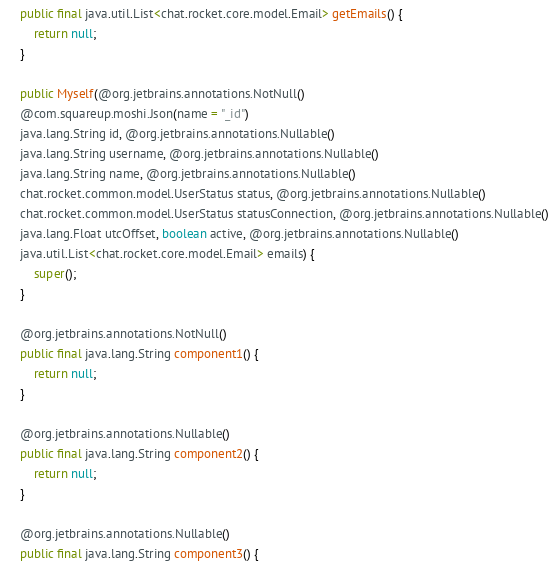Convert code to text. <code><loc_0><loc_0><loc_500><loc_500><_Java_>    public final java.util.List<chat.rocket.core.model.Email> getEmails() {
        return null;
    }
    
    public Myself(@org.jetbrains.annotations.NotNull()
    @com.squareup.moshi.Json(name = "_id")
    java.lang.String id, @org.jetbrains.annotations.Nullable()
    java.lang.String username, @org.jetbrains.annotations.Nullable()
    java.lang.String name, @org.jetbrains.annotations.Nullable()
    chat.rocket.common.model.UserStatus status, @org.jetbrains.annotations.Nullable()
    chat.rocket.common.model.UserStatus statusConnection, @org.jetbrains.annotations.Nullable()
    java.lang.Float utcOffset, boolean active, @org.jetbrains.annotations.Nullable()
    java.util.List<chat.rocket.core.model.Email> emails) {
        super();
    }
    
    @org.jetbrains.annotations.NotNull()
    public final java.lang.String component1() {
        return null;
    }
    
    @org.jetbrains.annotations.Nullable()
    public final java.lang.String component2() {
        return null;
    }
    
    @org.jetbrains.annotations.Nullable()
    public final java.lang.String component3() {</code> 